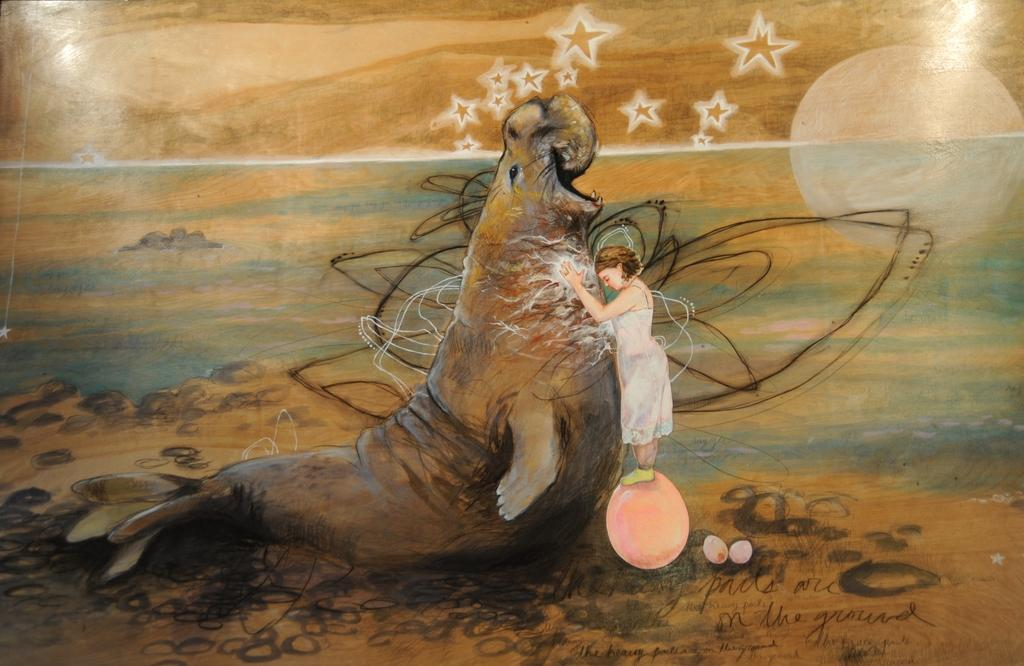What is the main subject of the image? The image contains a painting. What is the person in the painting doing? The person is standing on a ball in the painting. What animal is the person interacting with in the painting? The person is touching a sea lion in the water in the painting. What can be seen in the background of the painting? There are stars and the moon visible in the background of the painting. Can you see any clover growing near the coast in the image? There is no coast or clover present in the image; it features a painting with a person standing on a ball and interacting with a sea lion. 